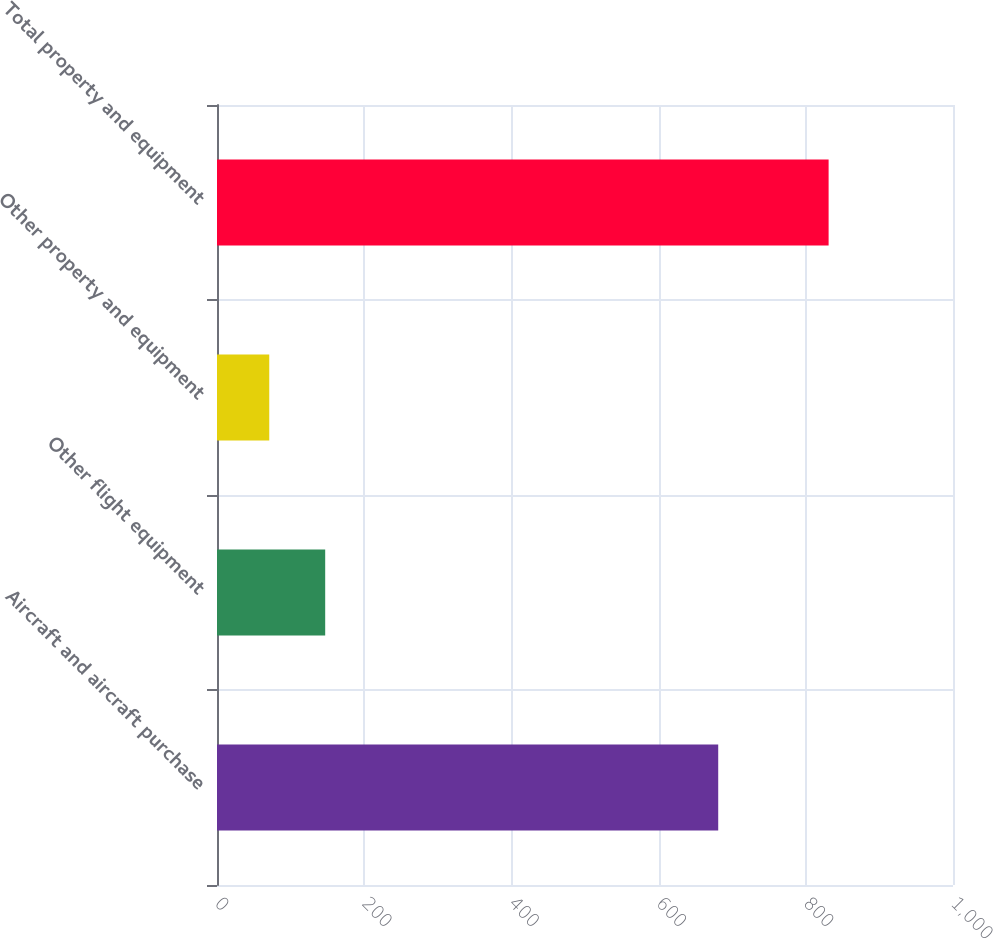Convert chart. <chart><loc_0><loc_0><loc_500><loc_500><bar_chart><fcel>Aircraft and aircraft purchase<fcel>Other flight equipment<fcel>Other property and equipment<fcel>Total property and equipment<nl><fcel>681<fcel>147<fcel>71<fcel>831<nl></chart> 